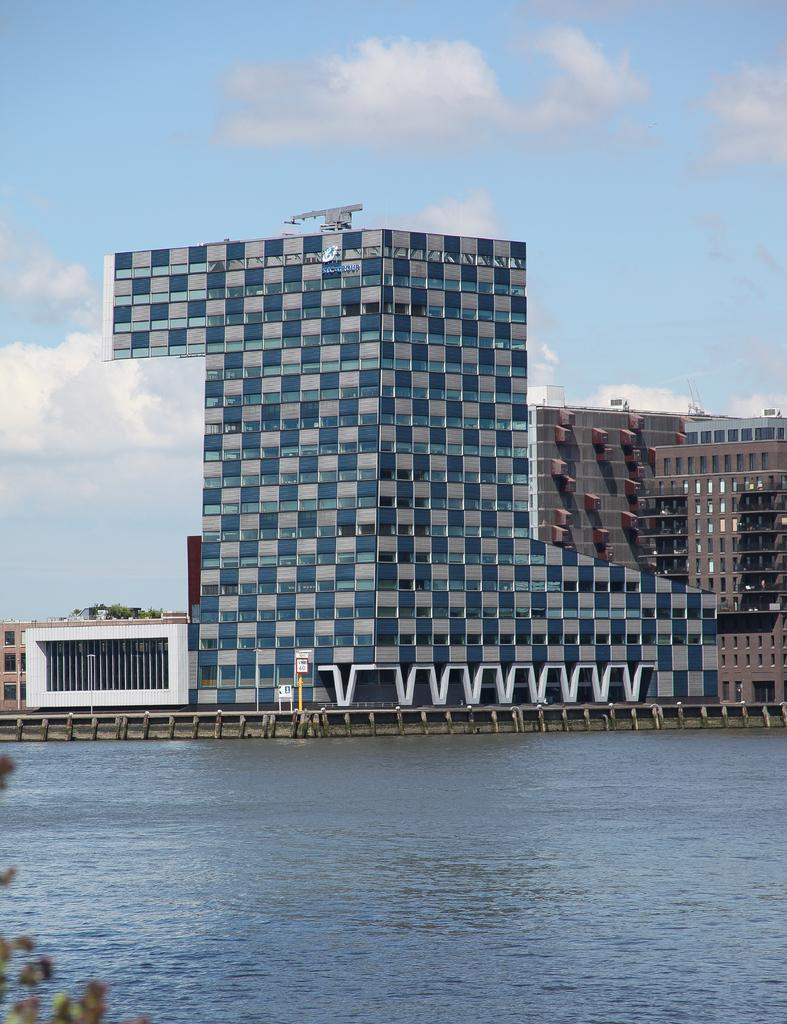What is visible in the image? Water, buildings, and the sky are visible in the image. Can you describe the sky in the image? The sky is visible in the background of the image, and clouds are present. Are there any kittens wearing masks in the image? There are no kittens or masks present in the image. 